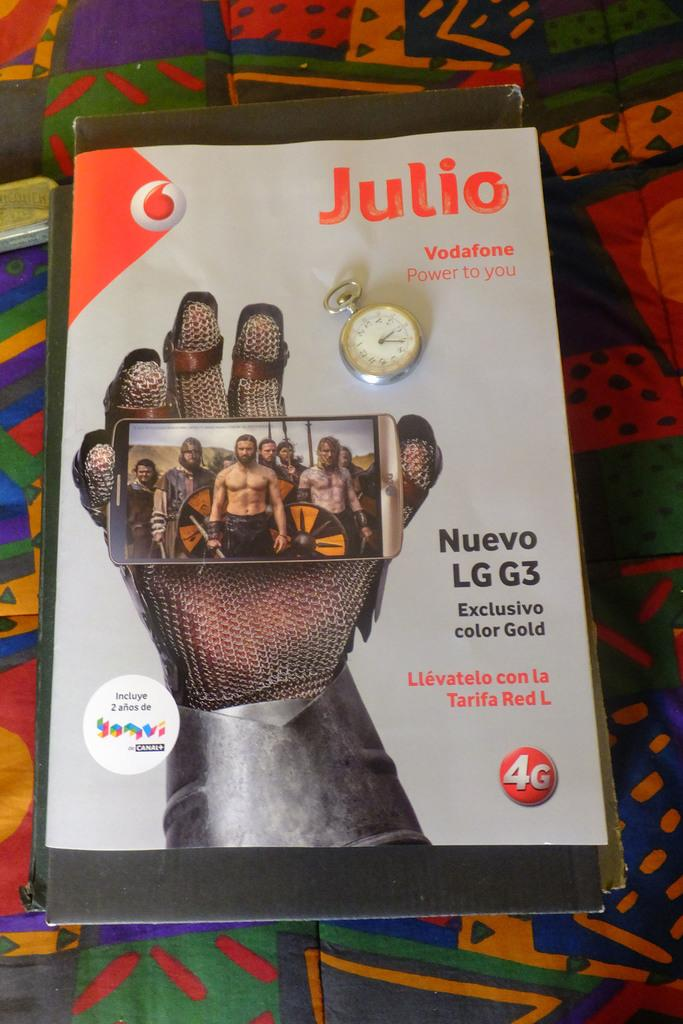<image>
Render a clear and concise summary of the photo. a magazine that has the name Julio on it 